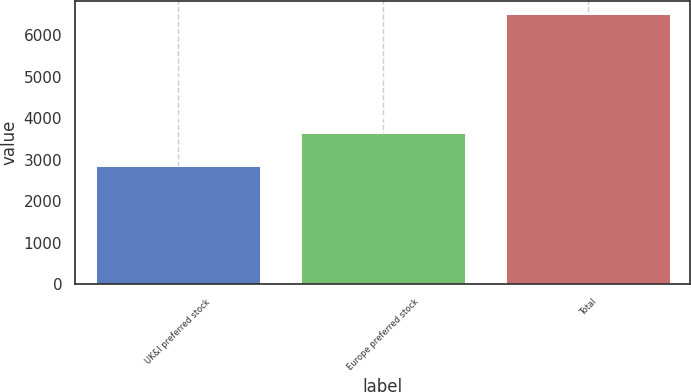<chart> <loc_0><loc_0><loc_500><loc_500><bar_chart><fcel>UK&I preferred stock<fcel>Europe preferred stock<fcel>Total<nl><fcel>2862<fcel>3642<fcel>6504<nl></chart> 